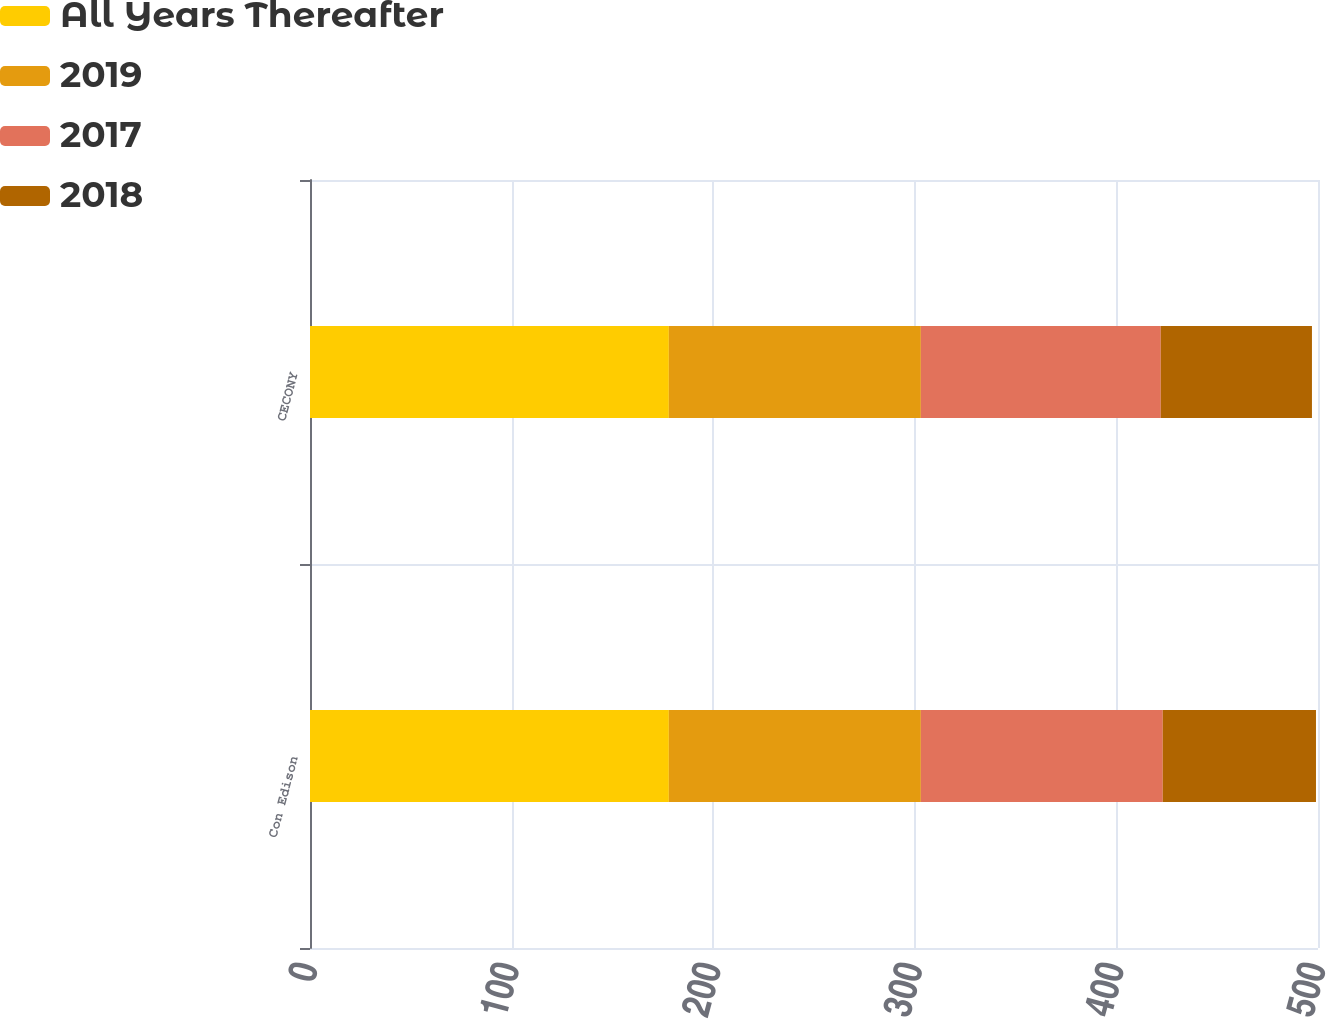Convert chart. <chart><loc_0><loc_0><loc_500><loc_500><stacked_bar_chart><ecel><fcel>Con Edison<fcel>CECONY<nl><fcel>All Years Thereafter<fcel>178<fcel>178<nl><fcel>2019<fcel>125<fcel>125<nl><fcel>2017<fcel>120<fcel>119<nl><fcel>2018<fcel>76<fcel>75<nl></chart> 